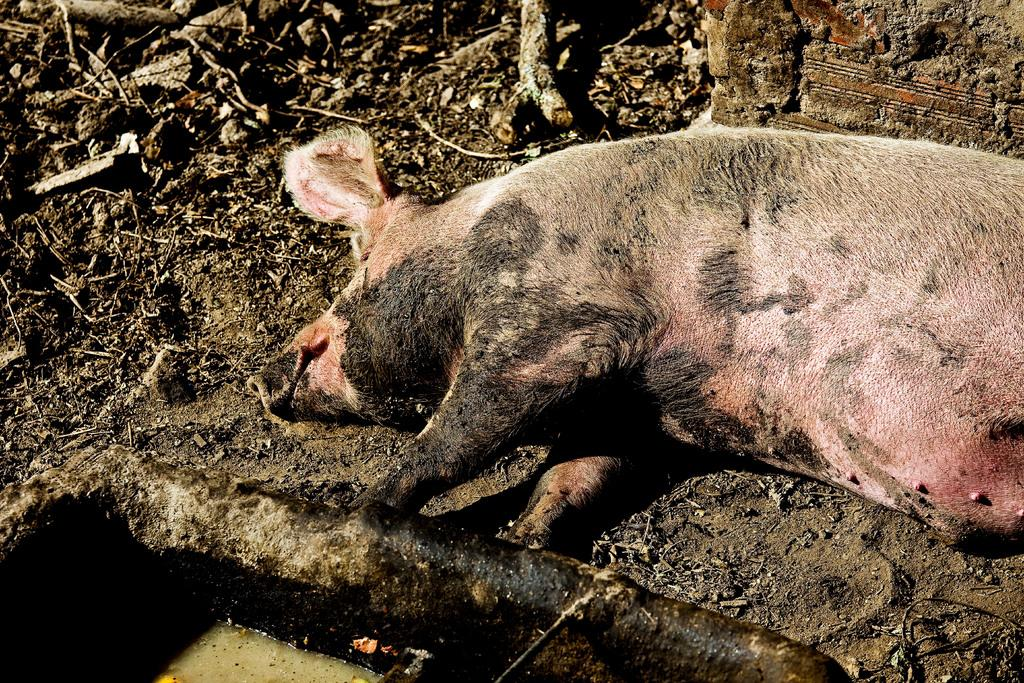What is located on the left side of the image? There is an object containing liquid on the left side of the image. What animal can be seen in the image? There is a pig lying on the ground in the image. What can be seen in the background of the image? There are sticks, a wall, and stones present in the background of the image. Can you tell me how the pig is preparing for its flight in the image? There is no indication of a flight or any preparation for it in the image; the pig is simply lying on the ground. What type of home does the pig live in, as seen in the image? The image does not show a home or any indication of where the pig lives. 